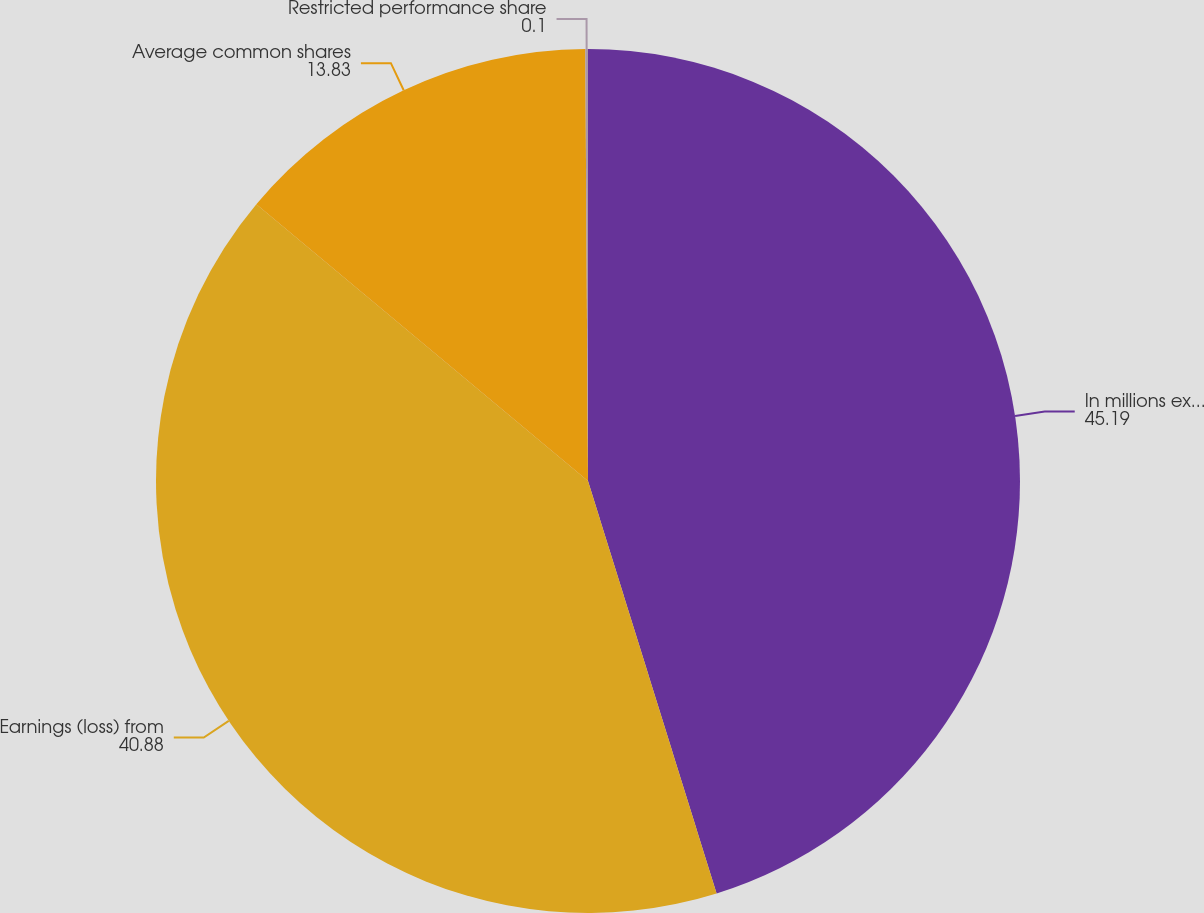<chart> <loc_0><loc_0><loc_500><loc_500><pie_chart><fcel>In millions except per share<fcel>Earnings (loss) from<fcel>Average common shares<fcel>Restricted performance share<nl><fcel>45.19%<fcel>40.88%<fcel>13.83%<fcel>0.1%<nl></chart> 